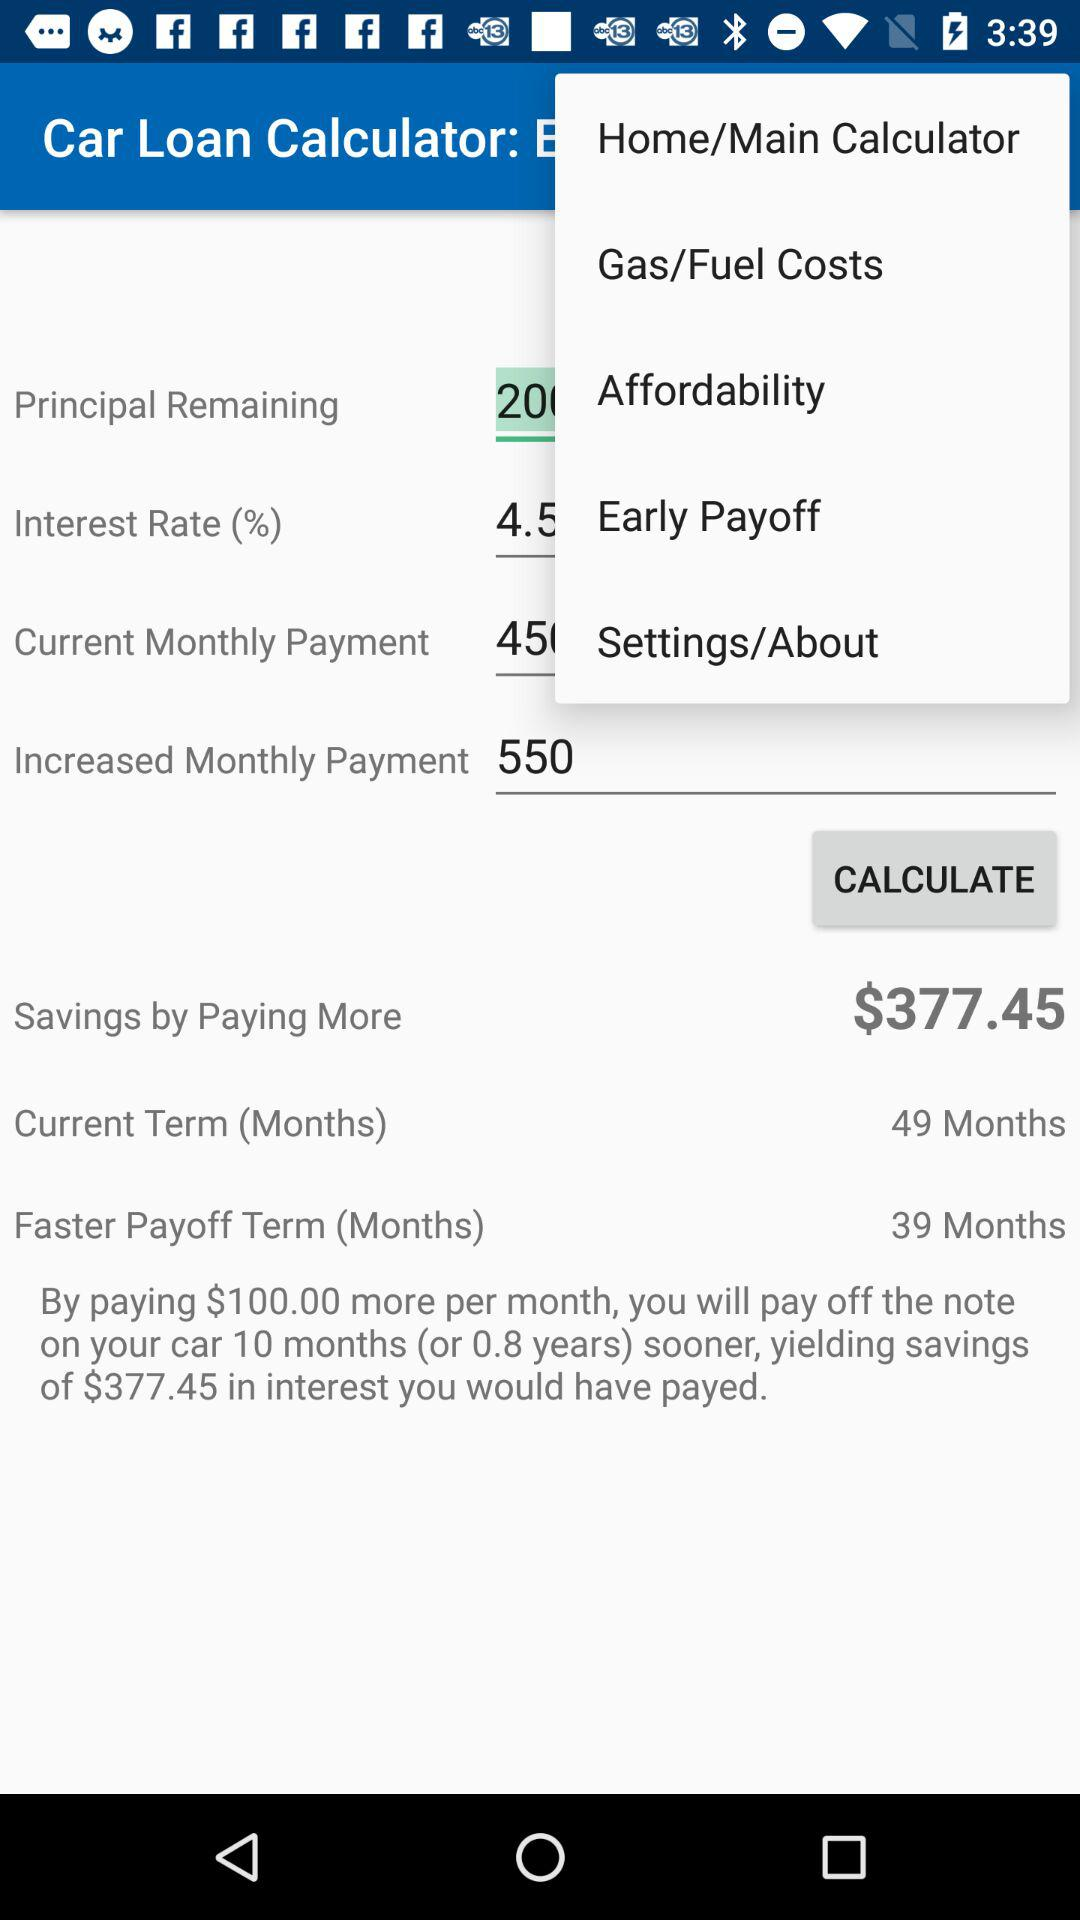How much is the increased monthly payment? The increased monthly payment is 550. 